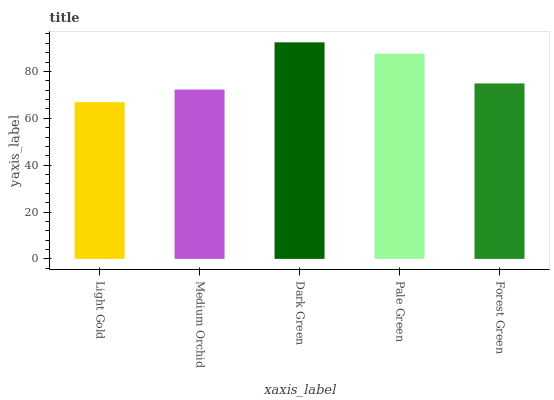Is Dark Green the maximum?
Answer yes or no. Yes. Is Medium Orchid the minimum?
Answer yes or no. No. Is Medium Orchid the maximum?
Answer yes or no. No. Is Medium Orchid greater than Light Gold?
Answer yes or no. Yes. Is Light Gold less than Medium Orchid?
Answer yes or no. Yes. Is Light Gold greater than Medium Orchid?
Answer yes or no. No. Is Medium Orchid less than Light Gold?
Answer yes or no. No. Is Forest Green the high median?
Answer yes or no. Yes. Is Forest Green the low median?
Answer yes or no. Yes. Is Light Gold the high median?
Answer yes or no. No. Is Light Gold the low median?
Answer yes or no. No. 